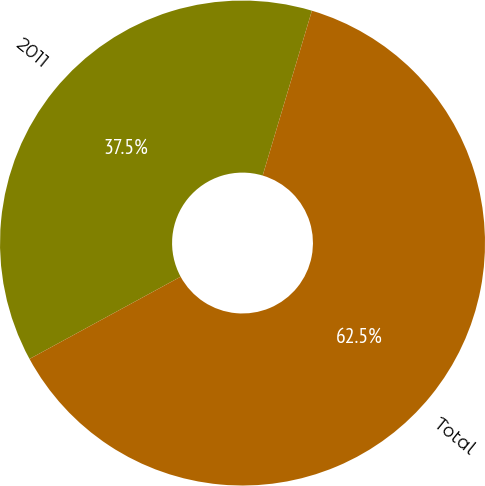Convert chart to OTSL. <chart><loc_0><loc_0><loc_500><loc_500><pie_chart><fcel>2011<fcel>Total<nl><fcel>37.55%<fcel>62.45%<nl></chart> 